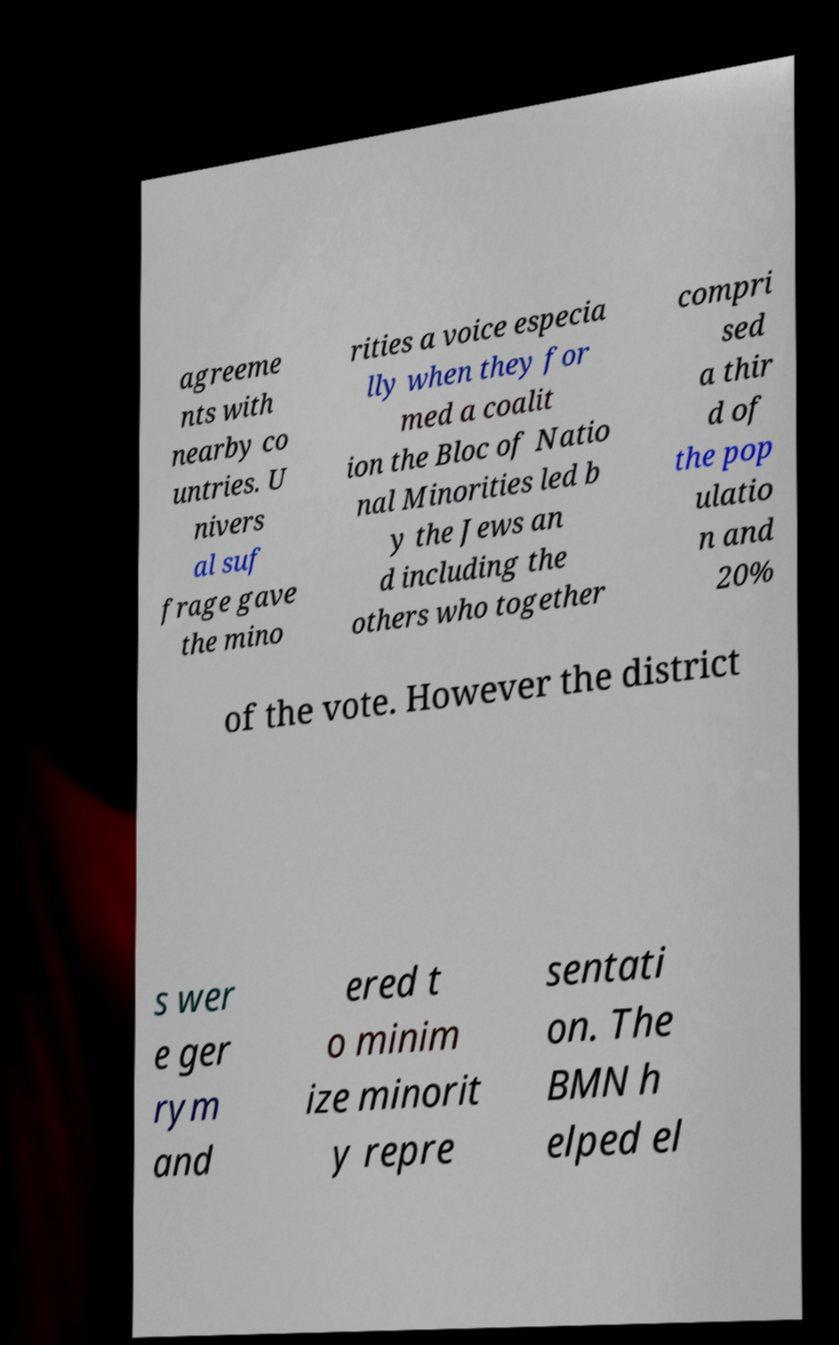There's text embedded in this image that I need extracted. Can you transcribe it verbatim? agreeme nts with nearby co untries. U nivers al suf frage gave the mino rities a voice especia lly when they for med a coalit ion the Bloc of Natio nal Minorities led b y the Jews an d including the others who together compri sed a thir d of the pop ulatio n and 20% of the vote. However the district s wer e ger rym and ered t o minim ize minorit y repre sentati on. The BMN h elped el 